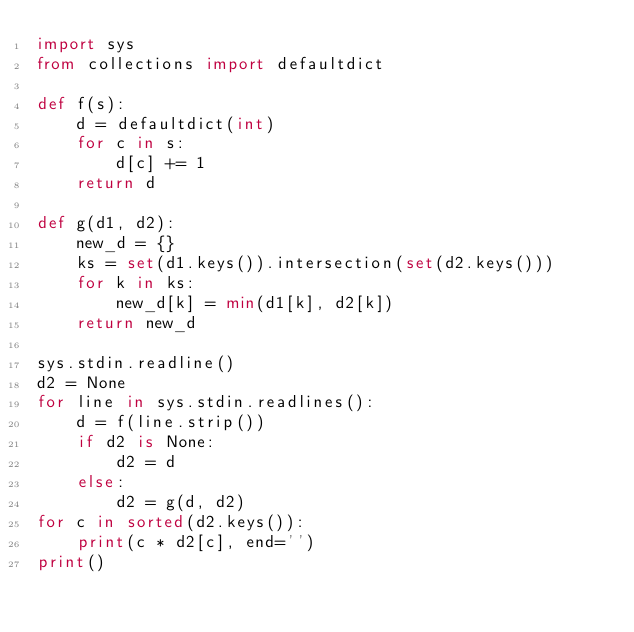Convert code to text. <code><loc_0><loc_0><loc_500><loc_500><_Python_>import sys
from collections import defaultdict

def f(s):
    d = defaultdict(int)
    for c in s:
        d[c] += 1
    return d

def g(d1, d2):
    new_d = {}
    ks = set(d1.keys()).intersection(set(d2.keys()))
    for k in ks:
        new_d[k] = min(d1[k], d2[k])
    return new_d

sys.stdin.readline()
d2 = None
for line in sys.stdin.readlines():
    d = f(line.strip())
    if d2 is None:
        d2 = d
    else:
        d2 = g(d, d2)
for c in sorted(d2.keys()):
    print(c * d2[c], end='')
print()
</code> 